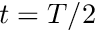<formula> <loc_0><loc_0><loc_500><loc_500>t = T / 2</formula> 